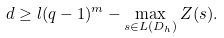<formula> <loc_0><loc_0><loc_500><loc_500>d \geq l ( q - 1 ) ^ { m } - \max _ { s \in L ( D _ { h } ) } Z ( s ) .</formula> 